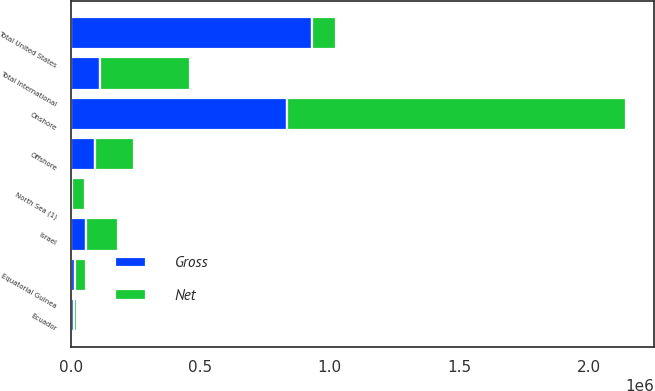Convert chart. <chart><loc_0><loc_0><loc_500><loc_500><stacked_bar_chart><ecel><fcel>Onshore<fcel>Offshore<fcel>Total United States<fcel>Equatorial Guinea<fcel>North Sea (1)<fcel>Israel<fcel>Ecuador<fcel>Total International<nl><fcel>Net<fcel>1.30882e+06<fcel>147945<fcel>94963<fcel>45203<fcel>48230<fcel>123552<fcel>12355<fcel>350078<nl><fcel>Gross<fcel>835445<fcel>94963<fcel>930408<fcel>15727<fcel>5671<fcel>58142<fcel>12355<fcel>111668<nl></chart> 